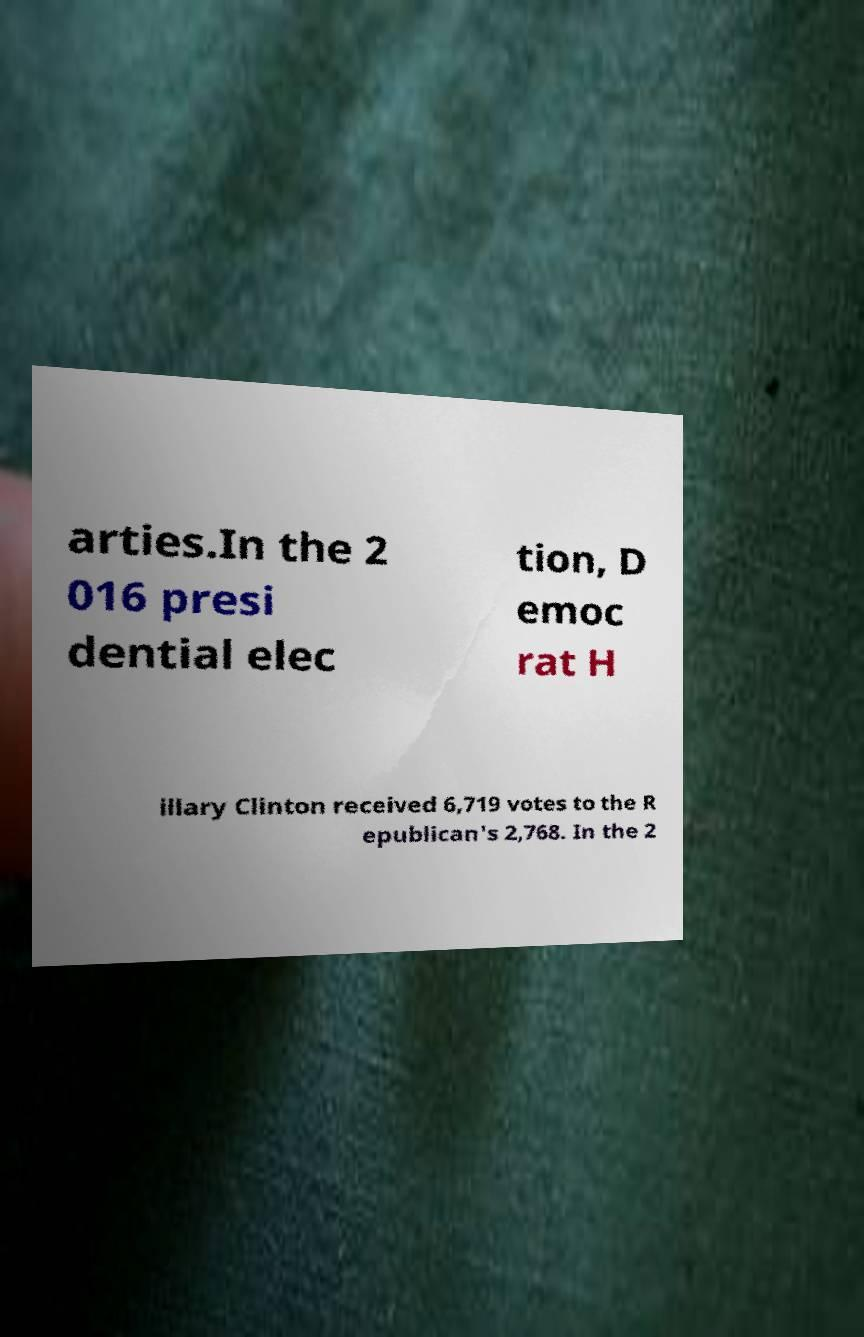Could you extract and type out the text from this image? arties.In the 2 016 presi dential elec tion, D emoc rat H illary Clinton received 6,719 votes to the R epublican's 2,768. In the 2 